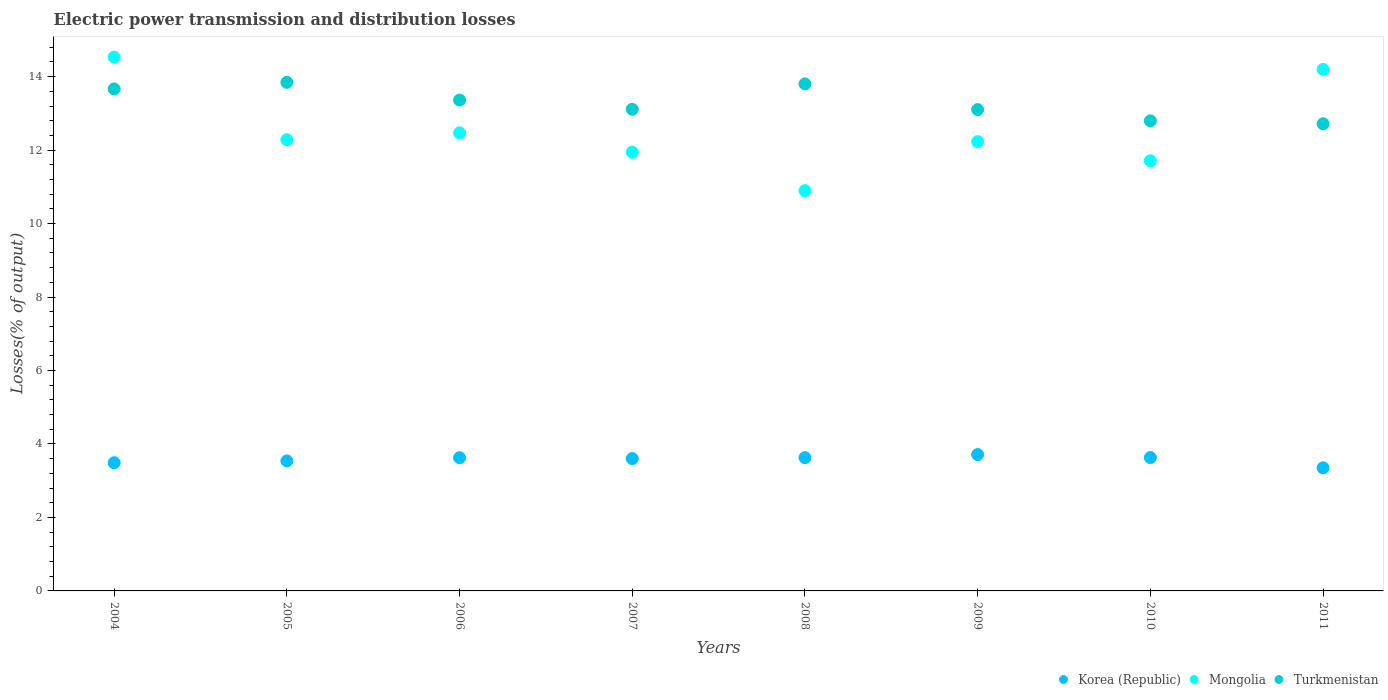Is the number of dotlines equal to the number of legend labels?
Provide a short and direct response. Yes. What is the electric power transmission and distribution losses in Korea (Republic) in 2010?
Your response must be concise. 3.63. Across all years, what is the maximum electric power transmission and distribution losses in Turkmenistan?
Ensure brevity in your answer.  13.85. Across all years, what is the minimum electric power transmission and distribution losses in Korea (Republic)?
Make the answer very short. 3.35. What is the total electric power transmission and distribution losses in Turkmenistan in the graph?
Offer a terse response. 106.41. What is the difference between the electric power transmission and distribution losses in Turkmenistan in 2010 and that in 2011?
Offer a terse response. 0.08. What is the difference between the electric power transmission and distribution losses in Turkmenistan in 2004 and the electric power transmission and distribution losses in Mongolia in 2007?
Give a very brief answer. 1.72. What is the average electric power transmission and distribution losses in Turkmenistan per year?
Your answer should be compact. 13.3. In the year 2005, what is the difference between the electric power transmission and distribution losses in Mongolia and electric power transmission and distribution losses in Turkmenistan?
Provide a short and direct response. -1.56. In how many years, is the electric power transmission and distribution losses in Mongolia greater than 1.2000000000000002 %?
Your answer should be very brief. 8. What is the ratio of the electric power transmission and distribution losses in Korea (Republic) in 2005 to that in 2007?
Your response must be concise. 0.98. Is the electric power transmission and distribution losses in Turkmenistan in 2005 less than that in 2007?
Provide a succinct answer. No. Is the difference between the electric power transmission and distribution losses in Mongolia in 2004 and 2005 greater than the difference between the electric power transmission and distribution losses in Turkmenistan in 2004 and 2005?
Your answer should be very brief. Yes. What is the difference between the highest and the second highest electric power transmission and distribution losses in Korea (Republic)?
Offer a very short reply. 0.08. What is the difference between the highest and the lowest electric power transmission and distribution losses in Mongolia?
Provide a succinct answer. 3.63. In how many years, is the electric power transmission and distribution losses in Mongolia greater than the average electric power transmission and distribution losses in Mongolia taken over all years?
Your answer should be very brief. 2. Is the electric power transmission and distribution losses in Turkmenistan strictly greater than the electric power transmission and distribution losses in Korea (Republic) over the years?
Offer a terse response. Yes. How many years are there in the graph?
Your answer should be compact. 8. What is the difference between two consecutive major ticks on the Y-axis?
Provide a short and direct response. 2. Does the graph contain grids?
Your response must be concise. No. What is the title of the graph?
Ensure brevity in your answer.  Electric power transmission and distribution losses. Does "Djibouti" appear as one of the legend labels in the graph?
Make the answer very short. No. What is the label or title of the X-axis?
Ensure brevity in your answer.  Years. What is the label or title of the Y-axis?
Ensure brevity in your answer.  Losses(% of output). What is the Losses(% of output) of Korea (Republic) in 2004?
Give a very brief answer. 3.49. What is the Losses(% of output) of Mongolia in 2004?
Make the answer very short. 14.53. What is the Losses(% of output) of Turkmenistan in 2004?
Give a very brief answer. 13.67. What is the Losses(% of output) in Korea (Republic) in 2005?
Make the answer very short. 3.54. What is the Losses(% of output) of Mongolia in 2005?
Your answer should be very brief. 12.28. What is the Losses(% of output) in Turkmenistan in 2005?
Keep it short and to the point. 13.85. What is the Losses(% of output) in Korea (Republic) in 2006?
Offer a terse response. 3.63. What is the Losses(% of output) in Mongolia in 2006?
Offer a very short reply. 12.47. What is the Losses(% of output) of Turkmenistan in 2006?
Ensure brevity in your answer.  13.36. What is the Losses(% of output) of Korea (Republic) in 2007?
Make the answer very short. 3.6. What is the Losses(% of output) in Mongolia in 2007?
Your answer should be very brief. 11.94. What is the Losses(% of output) of Turkmenistan in 2007?
Offer a terse response. 13.11. What is the Losses(% of output) of Korea (Republic) in 2008?
Offer a terse response. 3.63. What is the Losses(% of output) in Mongolia in 2008?
Keep it short and to the point. 10.9. What is the Losses(% of output) of Turkmenistan in 2008?
Give a very brief answer. 13.8. What is the Losses(% of output) in Korea (Republic) in 2009?
Provide a short and direct response. 3.71. What is the Losses(% of output) in Mongolia in 2009?
Your answer should be compact. 12.23. What is the Losses(% of output) of Turkmenistan in 2009?
Your answer should be compact. 13.1. What is the Losses(% of output) of Korea (Republic) in 2010?
Keep it short and to the point. 3.63. What is the Losses(% of output) in Mongolia in 2010?
Provide a short and direct response. 11.71. What is the Losses(% of output) in Turkmenistan in 2010?
Offer a very short reply. 12.8. What is the Losses(% of output) of Korea (Republic) in 2011?
Your response must be concise. 3.35. What is the Losses(% of output) in Mongolia in 2011?
Provide a short and direct response. 14.2. What is the Losses(% of output) of Turkmenistan in 2011?
Provide a short and direct response. 12.72. Across all years, what is the maximum Losses(% of output) in Korea (Republic)?
Make the answer very short. 3.71. Across all years, what is the maximum Losses(% of output) in Mongolia?
Provide a succinct answer. 14.53. Across all years, what is the maximum Losses(% of output) in Turkmenistan?
Your answer should be very brief. 13.85. Across all years, what is the minimum Losses(% of output) of Korea (Republic)?
Your answer should be compact. 3.35. Across all years, what is the minimum Losses(% of output) of Mongolia?
Keep it short and to the point. 10.9. Across all years, what is the minimum Losses(% of output) of Turkmenistan?
Make the answer very short. 12.72. What is the total Losses(% of output) of Korea (Republic) in the graph?
Give a very brief answer. 28.58. What is the total Losses(% of output) of Mongolia in the graph?
Provide a succinct answer. 100.27. What is the total Losses(% of output) in Turkmenistan in the graph?
Offer a very short reply. 106.41. What is the difference between the Losses(% of output) of Korea (Republic) in 2004 and that in 2005?
Provide a short and direct response. -0.05. What is the difference between the Losses(% of output) in Mongolia in 2004 and that in 2005?
Your answer should be compact. 2.25. What is the difference between the Losses(% of output) of Turkmenistan in 2004 and that in 2005?
Keep it short and to the point. -0.18. What is the difference between the Losses(% of output) in Korea (Republic) in 2004 and that in 2006?
Make the answer very short. -0.14. What is the difference between the Losses(% of output) of Mongolia in 2004 and that in 2006?
Offer a terse response. 2.06. What is the difference between the Losses(% of output) in Turkmenistan in 2004 and that in 2006?
Your answer should be compact. 0.3. What is the difference between the Losses(% of output) of Korea (Republic) in 2004 and that in 2007?
Offer a terse response. -0.11. What is the difference between the Losses(% of output) of Mongolia in 2004 and that in 2007?
Your response must be concise. 2.59. What is the difference between the Losses(% of output) in Turkmenistan in 2004 and that in 2007?
Provide a succinct answer. 0.55. What is the difference between the Losses(% of output) in Korea (Republic) in 2004 and that in 2008?
Make the answer very short. -0.14. What is the difference between the Losses(% of output) in Mongolia in 2004 and that in 2008?
Provide a short and direct response. 3.63. What is the difference between the Losses(% of output) in Turkmenistan in 2004 and that in 2008?
Give a very brief answer. -0.14. What is the difference between the Losses(% of output) of Korea (Republic) in 2004 and that in 2009?
Give a very brief answer. -0.22. What is the difference between the Losses(% of output) of Mongolia in 2004 and that in 2009?
Make the answer very short. 2.3. What is the difference between the Losses(% of output) of Turkmenistan in 2004 and that in 2009?
Provide a succinct answer. 0.56. What is the difference between the Losses(% of output) in Korea (Republic) in 2004 and that in 2010?
Your response must be concise. -0.14. What is the difference between the Losses(% of output) in Mongolia in 2004 and that in 2010?
Your response must be concise. 2.82. What is the difference between the Losses(% of output) in Turkmenistan in 2004 and that in 2010?
Give a very brief answer. 0.87. What is the difference between the Losses(% of output) in Korea (Republic) in 2004 and that in 2011?
Your response must be concise. 0.14. What is the difference between the Losses(% of output) of Mongolia in 2004 and that in 2011?
Offer a very short reply. 0.33. What is the difference between the Losses(% of output) of Turkmenistan in 2004 and that in 2011?
Your answer should be compact. 0.95. What is the difference between the Losses(% of output) of Korea (Republic) in 2005 and that in 2006?
Offer a terse response. -0.09. What is the difference between the Losses(% of output) of Mongolia in 2005 and that in 2006?
Your answer should be very brief. -0.19. What is the difference between the Losses(% of output) in Turkmenistan in 2005 and that in 2006?
Your response must be concise. 0.48. What is the difference between the Losses(% of output) of Korea (Republic) in 2005 and that in 2007?
Ensure brevity in your answer.  -0.06. What is the difference between the Losses(% of output) of Mongolia in 2005 and that in 2007?
Your response must be concise. 0.34. What is the difference between the Losses(% of output) of Turkmenistan in 2005 and that in 2007?
Provide a short and direct response. 0.73. What is the difference between the Losses(% of output) of Korea (Republic) in 2005 and that in 2008?
Your answer should be compact. -0.09. What is the difference between the Losses(% of output) in Mongolia in 2005 and that in 2008?
Keep it short and to the point. 1.39. What is the difference between the Losses(% of output) in Turkmenistan in 2005 and that in 2008?
Keep it short and to the point. 0.04. What is the difference between the Losses(% of output) in Korea (Republic) in 2005 and that in 2009?
Make the answer very short. -0.17. What is the difference between the Losses(% of output) of Mongolia in 2005 and that in 2009?
Your response must be concise. 0.05. What is the difference between the Losses(% of output) in Turkmenistan in 2005 and that in 2009?
Make the answer very short. 0.74. What is the difference between the Losses(% of output) in Korea (Republic) in 2005 and that in 2010?
Your answer should be compact. -0.09. What is the difference between the Losses(% of output) of Mongolia in 2005 and that in 2010?
Offer a terse response. 0.58. What is the difference between the Losses(% of output) in Turkmenistan in 2005 and that in 2010?
Make the answer very short. 1.05. What is the difference between the Losses(% of output) in Korea (Republic) in 2005 and that in 2011?
Offer a terse response. 0.19. What is the difference between the Losses(% of output) in Mongolia in 2005 and that in 2011?
Make the answer very short. -1.91. What is the difference between the Losses(% of output) of Turkmenistan in 2005 and that in 2011?
Ensure brevity in your answer.  1.13. What is the difference between the Losses(% of output) of Korea (Republic) in 2006 and that in 2007?
Provide a short and direct response. 0.02. What is the difference between the Losses(% of output) of Mongolia in 2006 and that in 2007?
Offer a terse response. 0.53. What is the difference between the Losses(% of output) of Turkmenistan in 2006 and that in 2007?
Keep it short and to the point. 0.25. What is the difference between the Losses(% of output) in Korea (Republic) in 2006 and that in 2008?
Your response must be concise. -0. What is the difference between the Losses(% of output) in Mongolia in 2006 and that in 2008?
Offer a very short reply. 1.57. What is the difference between the Losses(% of output) in Turkmenistan in 2006 and that in 2008?
Your answer should be very brief. -0.44. What is the difference between the Losses(% of output) in Korea (Republic) in 2006 and that in 2009?
Offer a very short reply. -0.09. What is the difference between the Losses(% of output) of Mongolia in 2006 and that in 2009?
Ensure brevity in your answer.  0.24. What is the difference between the Losses(% of output) of Turkmenistan in 2006 and that in 2009?
Your answer should be very brief. 0.26. What is the difference between the Losses(% of output) of Korea (Republic) in 2006 and that in 2010?
Your answer should be very brief. -0. What is the difference between the Losses(% of output) of Mongolia in 2006 and that in 2010?
Your response must be concise. 0.76. What is the difference between the Losses(% of output) of Turkmenistan in 2006 and that in 2010?
Make the answer very short. 0.57. What is the difference between the Losses(% of output) of Korea (Republic) in 2006 and that in 2011?
Offer a very short reply. 0.27. What is the difference between the Losses(% of output) of Mongolia in 2006 and that in 2011?
Provide a short and direct response. -1.73. What is the difference between the Losses(% of output) in Turkmenistan in 2006 and that in 2011?
Provide a short and direct response. 0.64. What is the difference between the Losses(% of output) in Korea (Republic) in 2007 and that in 2008?
Offer a terse response. -0.03. What is the difference between the Losses(% of output) in Mongolia in 2007 and that in 2008?
Give a very brief answer. 1.05. What is the difference between the Losses(% of output) of Turkmenistan in 2007 and that in 2008?
Your response must be concise. -0.69. What is the difference between the Losses(% of output) of Korea (Republic) in 2007 and that in 2009?
Your response must be concise. -0.11. What is the difference between the Losses(% of output) of Mongolia in 2007 and that in 2009?
Offer a terse response. -0.29. What is the difference between the Losses(% of output) in Turkmenistan in 2007 and that in 2009?
Provide a succinct answer. 0.01. What is the difference between the Losses(% of output) in Korea (Republic) in 2007 and that in 2010?
Ensure brevity in your answer.  -0.03. What is the difference between the Losses(% of output) of Mongolia in 2007 and that in 2010?
Your response must be concise. 0.23. What is the difference between the Losses(% of output) of Turkmenistan in 2007 and that in 2010?
Your answer should be very brief. 0.31. What is the difference between the Losses(% of output) in Korea (Republic) in 2007 and that in 2011?
Your response must be concise. 0.25. What is the difference between the Losses(% of output) in Mongolia in 2007 and that in 2011?
Offer a terse response. -2.25. What is the difference between the Losses(% of output) in Turkmenistan in 2007 and that in 2011?
Keep it short and to the point. 0.39. What is the difference between the Losses(% of output) in Korea (Republic) in 2008 and that in 2009?
Provide a succinct answer. -0.08. What is the difference between the Losses(% of output) of Mongolia in 2008 and that in 2009?
Provide a short and direct response. -1.33. What is the difference between the Losses(% of output) of Turkmenistan in 2008 and that in 2009?
Give a very brief answer. 0.7. What is the difference between the Losses(% of output) of Korea (Republic) in 2008 and that in 2010?
Offer a very short reply. -0. What is the difference between the Losses(% of output) of Mongolia in 2008 and that in 2010?
Keep it short and to the point. -0.81. What is the difference between the Losses(% of output) in Korea (Republic) in 2008 and that in 2011?
Provide a short and direct response. 0.28. What is the difference between the Losses(% of output) of Mongolia in 2008 and that in 2011?
Your answer should be compact. -3.3. What is the difference between the Losses(% of output) of Turkmenistan in 2008 and that in 2011?
Provide a short and direct response. 1.09. What is the difference between the Losses(% of output) in Korea (Republic) in 2009 and that in 2010?
Provide a succinct answer. 0.08. What is the difference between the Losses(% of output) of Mongolia in 2009 and that in 2010?
Your answer should be very brief. 0.52. What is the difference between the Losses(% of output) of Turkmenistan in 2009 and that in 2010?
Keep it short and to the point. 0.31. What is the difference between the Losses(% of output) of Korea (Republic) in 2009 and that in 2011?
Give a very brief answer. 0.36. What is the difference between the Losses(% of output) in Mongolia in 2009 and that in 2011?
Provide a short and direct response. -1.97. What is the difference between the Losses(% of output) of Turkmenistan in 2009 and that in 2011?
Offer a terse response. 0.39. What is the difference between the Losses(% of output) in Korea (Republic) in 2010 and that in 2011?
Provide a succinct answer. 0.28. What is the difference between the Losses(% of output) of Mongolia in 2010 and that in 2011?
Make the answer very short. -2.49. What is the difference between the Losses(% of output) of Turkmenistan in 2010 and that in 2011?
Give a very brief answer. 0.08. What is the difference between the Losses(% of output) of Korea (Republic) in 2004 and the Losses(% of output) of Mongolia in 2005?
Ensure brevity in your answer.  -8.79. What is the difference between the Losses(% of output) of Korea (Republic) in 2004 and the Losses(% of output) of Turkmenistan in 2005?
Ensure brevity in your answer.  -10.36. What is the difference between the Losses(% of output) in Mongolia in 2004 and the Losses(% of output) in Turkmenistan in 2005?
Provide a short and direct response. 0.69. What is the difference between the Losses(% of output) in Korea (Republic) in 2004 and the Losses(% of output) in Mongolia in 2006?
Your answer should be compact. -8.98. What is the difference between the Losses(% of output) in Korea (Republic) in 2004 and the Losses(% of output) in Turkmenistan in 2006?
Your answer should be compact. -9.87. What is the difference between the Losses(% of output) of Mongolia in 2004 and the Losses(% of output) of Turkmenistan in 2006?
Offer a terse response. 1.17. What is the difference between the Losses(% of output) of Korea (Republic) in 2004 and the Losses(% of output) of Mongolia in 2007?
Keep it short and to the point. -8.45. What is the difference between the Losses(% of output) in Korea (Republic) in 2004 and the Losses(% of output) in Turkmenistan in 2007?
Offer a very short reply. -9.62. What is the difference between the Losses(% of output) in Mongolia in 2004 and the Losses(% of output) in Turkmenistan in 2007?
Give a very brief answer. 1.42. What is the difference between the Losses(% of output) of Korea (Republic) in 2004 and the Losses(% of output) of Mongolia in 2008?
Keep it short and to the point. -7.41. What is the difference between the Losses(% of output) of Korea (Republic) in 2004 and the Losses(% of output) of Turkmenistan in 2008?
Offer a terse response. -10.31. What is the difference between the Losses(% of output) of Mongolia in 2004 and the Losses(% of output) of Turkmenistan in 2008?
Your answer should be very brief. 0.73. What is the difference between the Losses(% of output) in Korea (Republic) in 2004 and the Losses(% of output) in Mongolia in 2009?
Give a very brief answer. -8.74. What is the difference between the Losses(% of output) in Korea (Republic) in 2004 and the Losses(% of output) in Turkmenistan in 2009?
Your answer should be compact. -9.61. What is the difference between the Losses(% of output) in Mongolia in 2004 and the Losses(% of output) in Turkmenistan in 2009?
Your answer should be very brief. 1.43. What is the difference between the Losses(% of output) in Korea (Republic) in 2004 and the Losses(% of output) in Mongolia in 2010?
Provide a succinct answer. -8.22. What is the difference between the Losses(% of output) of Korea (Republic) in 2004 and the Losses(% of output) of Turkmenistan in 2010?
Your response must be concise. -9.31. What is the difference between the Losses(% of output) of Mongolia in 2004 and the Losses(% of output) of Turkmenistan in 2010?
Provide a short and direct response. 1.74. What is the difference between the Losses(% of output) in Korea (Republic) in 2004 and the Losses(% of output) in Mongolia in 2011?
Provide a succinct answer. -10.71. What is the difference between the Losses(% of output) of Korea (Republic) in 2004 and the Losses(% of output) of Turkmenistan in 2011?
Ensure brevity in your answer.  -9.23. What is the difference between the Losses(% of output) in Mongolia in 2004 and the Losses(% of output) in Turkmenistan in 2011?
Offer a terse response. 1.81. What is the difference between the Losses(% of output) of Korea (Republic) in 2005 and the Losses(% of output) of Mongolia in 2006?
Keep it short and to the point. -8.93. What is the difference between the Losses(% of output) of Korea (Republic) in 2005 and the Losses(% of output) of Turkmenistan in 2006?
Give a very brief answer. -9.82. What is the difference between the Losses(% of output) in Mongolia in 2005 and the Losses(% of output) in Turkmenistan in 2006?
Your response must be concise. -1.08. What is the difference between the Losses(% of output) of Korea (Republic) in 2005 and the Losses(% of output) of Mongolia in 2007?
Keep it short and to the point. -8.4. What is the difference between the Losses(% of output) of Korea (Republic) in 2005 and the Losses(% of output) of Turkmenistan in 2007?
Keep it short and to the point. -9.57. What is the difference between the Losses(% of output) of Mongolia in 2005 and the Losses(% of output) of Turkmenistan in 2007?
Provide a short and direct response. -0.83. What is the difference between the Losses(% of output) of Korea (Republic) in 2005 and the Losses(% of output) of Mongolia in 2008?
Make the answer very short. -7.36. What is the difference between the Losses(% of output) in Korea (Republic) in 2005 and the Losses(% of output) in Turkmenistan in 2008?
Provide a short and direct response. -10.26. What is the difference between the Losses(% of output) in Mongolia in 2005 and the Losses(% of output) in Turkmenistan in 2008?
Give a very brief answer. -1.52. What is the difference between the Losses(% of output) of Korea (Republic) in 2005 and the Losses(% of output) of Mongolia in 2009?
Make the answer very short. -8.69. What is the difference between the Losses(% of output) of Korea (Republic) in 2005 and the Losses(% of output) of Turkmenistan in 2009?
Offer a terse response. -9.56. What is the difference between the Losses(% of output) in Mongolia in 2005 and the Losses(% of output) in Turkmenistan in 2009?
Provide a succinct answer. -0.82. What is the difference between the Losses(% of output) of Korea (Republic) in 2005 and the Losses(% of output) of Mongolia in 2010?
Your response must be concise. -8.17. What is the difference between the Losses(% of output) of Korea (Republic) in 2005 and the Losses(% of output) of Turkmenistan in 2010?
Ensure brevity in your answer.  -9.26. What is the difference between the Losses(% of output) in Mongolia in 2005 and the Losses(% of output) in Turkmenistan in 2010?
Your answer should be compact. -0.51. What is the difference between the Losses(% of output) in Korea (Republic) in 2005 and the Losses(% of output) in Mongolia in 2011?
Your response must be concise. -10.66. What is the difference between the Losses(% of output) of Korea (Republic) in 2005 and the Losses(% of output) of Turkmenistan in 2011?
Offer a terse response. -9.18. What is the difference between the Losses(% of output) in Mongolia in 2005 and the Losses(% of output) in Turkmenistan in 2011?
Your response must be concise. -0.43. What is the difference between the Losses(% of output) in Korea (Republic) in 2006 and the Losses(% of output) in Mongolia in 2007?
Your response must be concise. -8.32. What is the difference between the Losses(% of output) of Korea (Republic) in 2006 and the Losses(% of output) of Turkmenistan in 2007?
Provide a short and direct response. -9.49. What is the difference between the Losses(% of output) in Mongolia in 2006 and the Losses(% of output) in Turkmenistan in 2007?
Provide a succinct answer. -0.64. What is the difference between the Losses(% of output) in Korea (Republic) in 2006 and the Losses(% of output) in Mongolia in 2008?
Offer a very short reply. -7.27. What is the difference between the Losses(% of output) in Korea (Republic) in 2006 and the Losses(% of output) in Turkmenistan in 2008?
Offer a terse response. -10.18. What is the difference between the Losses(% of output) of Mongolia in 2006 and the Losses(% of output) of Turkmenistan in 2008?
Provide a short and direct response. -1.33. What is the difference between the Losses(% of output) in Korea (Republic) in 2006 and the Losses(% of output) in Mongolia in 2009?
Provide a succinct answer. -8.6. What is the difference between the Losses(% of output) of Korea (Republic) in 2006 and the Losses(% of output) of Turkmenistan in 2009?
Provide a short and direct response. -9.48. What is the difference between the Losses(% of output) of Mongolia in 2006 and the Losses(% of output) of Turkmenistan in 2009?
Your response must be concise. -0.63. What is the difference between the Losses(% of output) of Korea (Republic) in 2006 and the Losses(% of output) of Mongolia in 2010?
Your response must be concise. -8.08. What is the difference between the Losses(% of output) in Korea (Republic) in 2006 and the Losses(% of output) in Turkmenistan in 2010?
Keep it short and to the point. -9.17. What is the difference between the Losses(% of output) of Mongolia in 2006 and the Losses(% of output) of Turkmenistan in 2010?
Your answer should be very brief. -0.33. What is the difference between the Losses(% of output) of Korea (Republic) in 2006 and the Losses(% of output) of Mongolia in 2011?
Your response must be concise. -10.57. What is the difference between the Losses(% of output) of Korea (Republic) in 2006 and the Losses(% of output) of Turkmenistan in 2011?
Ensure brevity in your answer.  -9.09. What is the difference between the Losses(% of output) of Mongolia in 2006 and the Losses(% of output) of Turkmenistan in 2011?
Provide a short and direct response. -0.25. What is the difference between the Losses(% of output) in Korea (Republic) in 2007 and the Losses(% of output) in Mongolia in 2008?
Your response must be concise. -7.29. What is the difference between the Losses(% of output) in Korea (Republic) in 2007 and the Losses(% of output) in Turkmenistan in 2008?
Give a very brief answer. -10.2. What is the difference between the Losses(% of output) of Mongolia in 2007 and the Losses(% of output) of Turkmenistan in 2008?
Your answer should be compact. -1.86. What is the difference between the Losses(% of output) of Korea (Republic) in 2007 and the Losses(% of output) of Mongolia in 2009?
Provide a succinct answer. -8.63. What is the difference between the Losses(% of output) in Korea (Republic) in 2007 and the Losses(% of output) in Turkmenistan in 2009?
Keep it short and to the point. -9.5. What is the difference between the Losses(% of output) of Mongolia in 2007 and the Losses(% of output) of Turkmenistan in 2009?
Ensure brevity in your answer.  -1.16. What is the difference between the Losses(% of output) in Korea (Republic) in 2007 and the Losses(% of output) in Mongolia in 2010?
Provide a short and direct response. -8.11. What is the difference between the Losses(% of output) of Korea (Republic) in 2007 and the Losses(% of output) of Turkmenistan in 2010?
Provide a succinct answer. -9.19. What is the difference between the Losses(% of output) of Mongolia in 2007 and the Losses(% of output) of Turkmenistan in 2010?
Make the answer very short. -0.85. What is the difference between the Losses(% of output) in Korea (Republic) in 2007 and the Losses(% of output) in Mongolia in 2011?
Give a very brief answer. -10.59. What is the difference between the Losses(% of output) in Korea (Republic) in 2007 and the Losses(% of output) in Turkmenistan in 2011?
Ensure brevity in your answer.  -9.11. What is the difference between the Losses(% of output) of Mongolia in 2007 and the Losses(% of output) of Turkmenistan in 2011?
Your answer should be very brief. -0.78. What is the difference between the Losses(% of output) in Korea (Republic) in 2008 and the Losses(% of output) in Mongolia in 2009?
Provide a short and direct response. -8.6. What is the difference between the Losses(% of output) in Korea (Republic) in 2008 and the Losses(% of output) in Turkmenistan in 2009?
Your answer should be compact. -9.48. What is the difference between the Losses(% of output) of Mongolia in 2008 and the Losses(% of output) of Turkmenistan in 2009?
Provide a succinct answer. -2.21. What is the difference between the Losses(% of output) in Korea (Republic) in 2008 and the Losses(% of output) in Mongolia in 2010?
Provide a succinct answer. -8.08. What is the difference between the Losses(% of output) in Korea (Republic) in 2008 and the Losses(% of output) in Turkmenistan in 2010?
Your answer should be very brief. -9.17. What is the difference between the Losses(% of output) in Mongolia in 2008 and the Losses(% of output) in Turkmenistan in 2010?
Offer a very short reply. -1.9. What is the difference between the Losses(% of output) in Korea (Republic) in 2008 and the Losses(% of output) in Mongolia in 2011?
Give a very brief answer. -10.57. What is the difference between the Losses(% of output) in Korea (Republic) in 2008 and the Losses(% of output) in Turkmenistan in 2011?
Make the answer very short. -9.09. What is the difference between the Losses(% of output) of Mongolia in 2008 and the Losses(% of output) of Turkmenistan in 2011?
Your answer should be compact. -1.82. What is the difference between the Losses(% of output) of Korea (Republic) in 2009 and the Losses(% of output) of Mongolia in 2010?
Your response must be concise. -8. What is the difference between the Losses(% of output) of Korea (Republic) in 2009 and the Losses(% of output) of Turkmenistan in 2010?
Your response must be concise. -9.08. What is the difference between the Losses(% of output) in Mongolia in 2009 and the Losses(% of output) in Turkmenistan in 2010?
Make the answer very short. -0.57. What is the difference between the Losses(% of output) in Korea (Republic) in 2009 and the Losses(% of output) in Mongolia in 2011?
Ensure brevity in your answer.  -10.48. What is the difference between the Losses(% of output) in Korea (Republic) in 2009 and the Losses(% of output) in Turkmenistan in 2011?
Make the answer very short. -9. What is the difference between the Losses(% of output) of Mongolia in 2009 and the Losses(% of output) of Turkmenistan in 2011?
Your answer should be compact. -0.49. What is the difference between the Losses(% of output) in Korea (Republic) in 2010 and the Losses(% of output) in Mongolia in 2011?
Provide a succinct answer. -10.57. What is the difference between the Losses(% of output) in Korea (Republic) in 2010 and the Losses(% of output) in Turkmenistan in 2011?
Your answer should be compact. -9.09. What is the difference between the Losses(% of output) of Mongolia in 2010 and the Losses(% of output) of Turkmenistan in 2011?
Your answer should be compact. -1.01. What is the average Losses(% of output) in Korea (Republic) per year?
Your answer should be compact. 3.57. What is the average Losses(% of output) in Mongolia per year?
Your response must be concise. 12.53. What is the average Losses(% of output) in Turkmenistan per year?
Ensure brevity in your answer.  13.3. In the year 2004, what is the difference between the Losses(% of output) of Korea (Republic) and Losses(% of output) of Mongolia?
Provide a succinct answer. -11.04. In the year 2004, what is the difference between the Losses(% of output) in Korea (Republic) and Losses(% of output) in Turkmenistan?
Offer a very short reply. -10.18. In the year 2004, what is the difference between the Losses(% of output) of Mongolia and Losses(% of output) of Turkmenistan?
Ensure brevity in your answer.  0.87. In the year 2005, what is the difference between the Losses(% of output) of Korea (Republic) and Losses(% of output) of Mongolia?
Your answer should be very brief. -8.74. In the year 2005, what is the difference between the Losses(% of output) of Korea (Republic) and Losses(% of output) of Turkmenistan?
Give a very brief answer. -10.31. In the year 2005, what is the difference between the Losses(% of output) of Mongolia and Losses(% of output) of Turkmenistan?
Offer a very short reply. -1.56. In the year 2006, what is the difference between the Losses(% of output) of Korea (Republic) and Losses(% of output) of Mongolia?
Offer a terse response. -8.85. In the year 2006, what is the difference between the Losses(% of output) in Korea (Republic) and Losses(% of output) in Turkmenistan?
Keep it short and to the point. -9.74. In the year 2006, what is the difference between the Losses(% of output) of Mongolia and Losses(% of output) of Turkmenistan?
Offer a very short reply. -0.89. In the year 2007, what is the difference between the Losses(% of output) in Korea (Republic) and Losses(% of output) in Mongolia?
Your answer should be compact. -8.34. In the year 2007, what is the difference between the Losses(% of output) of Korea (Republic) and Losses(% of output) of Turkmenistan?
Make the answer very short. -9.51. In the year 2007, what is the difference between the Losses(% of output) in Mongolia and Losses(% of output) in Turkmenistan?
Make the answer very short. -1.17. In the year 2008, what is the difference between the Losses(% of output) in Korea (Republic) and Losses(% of output) in Mongolia?
Provide a short and direct response. -7.27. In the year 2008, what is the difference between the Losses(% of output) in Korea (Republic) and Losses(% of output) in Turkmenistan?
Offer a very short reply. -10.18. In the year 2008, what is the difference between the Losses(% of output) of Mongolia and Losses(% of output) of Turkmenistan?
Ensure brevity in your answer.  -2.91. In the year 2009, what is the difference between the Losses(% of output) in Korea (Republic) and Losses(% of output) in Mongolia?
Provide a short and direct response. -8.52. In the year 2009, what is the difference between the Losses(% of output) of Korea (Republic) and Losses(% of output) of Turkmenistan?
Your response must be concise. -9.39. In the year 2009, what is the difference between the Losses(% of output) in Mongolia and Losses(% of output) in Turkmenistan?
Offer a very short reply. -0.87. In the year 2010, what is the difference between the Losses(% of output) in Korea (Republic) and Losses(% of output) in Mongolia?
Ensure brevity in your answer.  -8.08. In the year 2010, what is the difference between the Losses(% of output) of Korea (Republic) and Losses(% of output) of Turkmenistan?
Your response must be concise. -9.17. In the year 2010, what is the difference between the Losses(% of output) in Mongolia and Losses(% of output) in Turkmenistan?
Ensure brevity in your answer.  -1.09. In the year 2011, what is the difference between the Losses(% of output) of Korea (Republic) and Losses(% of output) of Mongolia?
Ensure brevity in your answer.  -10.85. In the year 2011, what is the difference between the Losses(% of output) of Korea (Republic) and Losses(% of output) of Turkmenistan?
Keep it short and to the point. -9.37. In the year 2011, what is the difference between the Losses(% of output) in Mongolia and Losses(% of output) in Turkmenistan?
Offer a very short reply. 1.48. What is the ratio of the Losses(% of output) of Mongolia in 2004 to that in 2005?
Offer a very short reply. 1.18. What is the ratio of the Losses(% of output) in Turkmenistan in 2004 to that in 2005?
Ensure brevity in your answer.  0.99. What is the ratio of the Losses(% of output) in Korea (Republic) in 2004 to that in 2006?
Your response must be concise. 0.96. What is the ratio of the Losses(% of output) of Mongolia in 2004 to that in 2006?
Make the answer very short. 1.17. What is the ratio of the Losses(% of output) of Turkmenistan in 2004 to that in 2006?
Your answer should be compact. 1.02. What is the ratio of the Losses(% of output) of Korea (Republic) in 2004 to that in 2007?
Your answer should be compact. 0.97. What is the ratio of the Losses(% of output) in Mongolia in 2004 to that in 2007?
Make the answer very short. 1.22. What is the ratio of the Losses(% of output) in Turkmenistan in 2004 to that in 2007?
Give a very brief answer. 1.04. What is the ratio of the Losses(% of output) in Korea (Republic) in 2004 to that in 2008?
Provide a short and direct response. 0.96. What is the ratio of the Losses(% of output) of Mongolia in 2004 to that in 2008?
Your response must be concise. 1.33. What is the ratio of the Losses(% of output) of Korea (Republic) in 2004 to that in 2009?
Offer a terse response. 0.94. What is the ratio of the Losses(% of output) in Mongolia in 2004 to that in 2009?
Your response must be concise. 1.19. What is the ratio of the Losses(% of output) in Turkmenistan in 2004 to that in 2009?
Offer a very short reply. 1.04. What is the ratio of the Losses(% of output) in Korea (Republic) in 2004 to that in 2010?
Keep it short and to the point. 0.96. What is the ratio of the Losses(% of output) in Mongolia in 2004 to that in 2010?
Give a very brief answer. 1.24. What is the ratio of the Losses(% of output) in Turkmenistan in 2004 to that in 2010?
Provide a short and direct response. 1.07. What is the ratio of the Losses(% of output) in Korea (Republic) in 2004 to that in 2011?
Keep it short and to the point. 1.04. What is the ratio of the Losses(% of output) in Mongolia in 2004 to that in 2011?
Your answer should be very brief. 1.02. What is the ratio of the Losses(% of output) of Turkmenistan in 2004 to that in 2011?
Make the answer very short. 1.07. What is the ratio of the Losses(% of output) in Korea (Republic) in 2005 to that in 2006?
Your answer should be very brief. 0.98. What is the ratio of the Losses(% of output) in Mongolia in 2005 to that in 2006?
Offer a very short reply. 0.98. What is the ratio of the Losses(% of output) in Turkmenistan in 2005 to that in 2006?
Make the answer very short. 1.04. What is the ratio of the Losses(% of output) of Korea (Republic) in 2005 to that in 2007?
Offer a very short reply. 0.98. What is the ratio of the Losses(% of output) in Mongolia in 2005 to that in 2007?
Make the answer very short. 1.03. What is the ratio of the Losses(% of output) of Turkmenistan in 2005 to that in 2007?
Your answer should be compact. 1.06. What is the ratio of the Losses(% of output) in Korea (Republic) in 2005 to that in 2008?
Keep it short and to the point. 0.98. What is the ratio of the Losses(% of output) of Mongolia in 2005 to that in 2008?
Provide a succinct answer. 1.13. What is the ratio of the Losses(% of output) of Turkmenistan in 2005 to that in 2008?
Your answer should be very brief. 1. What is the ratio of the Losses(% of output) in Korea (Republic) in 2005 to that in 2009?
Provide a succinct answer. 0.95. What is the ratio of the Losses(% of output) in Mongolia in 2005 to that in 2009?
Your answer should be compact. 1. What is the ratio of the Losses(% of output) of Turkmenistan in 2005 to that in 2009?
Make the answer very short. 1.06. What is the ratio of the Losses(% of output) of Korea (Republic) in 2005 to that in 2010?
Offer a very short reply. 0.97. What is the ratio of the Losses(% of output) in Mongolia in 2005 to that in 2010?
Provide a succinct answer. 1.05. What is the ratio of the Losses(% of output) of Turkmenistan in 2005 to that in 2010?
Give a very brief answer. 1.08. What is the ratio of the Losses(% of output) of Korea (Republic) in 2005 to that in 2011?
Ensure brevity in your answer.  1.06. What is the ratio of the Losses(% of output) in Mongolia in 2005 to that in 2011?
Make the answer very short. 0.87. What is the ratio of the Losses(% of output) in Turkmenistan in 2005 to that in 2011?
Your response must be concise. 1.09. What is the ratio of the Losses(% of output) in Mongolia in 2006 to that in 2007?
Your answer should be very brief. 1.04. What is the ratio of the Losses(% of output) of Turkmenistan in 2006 to that in 2007?
Your response must be concise. 1.02. What is the ratio of the Losses(% of output) in Korea (Republic) in 2006 to that in 2008?
Ensure brevity in your answer.  1. What is the ratio of the Losses(% of output) of Mongolia in 2006 to that in 2008?
Provide a succinct answer. 1.14. What is the ratio of the Losses(% of output) in Turkmenistan in 2006 to that in 2008?
Keep it short and to the point. 0.97. What is the ratio of the Losses(% of output) of Korea (Republic) in 2006 to that in 2009?
Your answer should be very brief. 0.98. What is the ratio of the Losses(% of output) in Mongolia in 2006 to that in 2009?
Make the answer very short. 1.02. What is the ratio of the Losses(% of output) of Turkmenistan in 2006 to that in 2009?
Offer a terse response. 1.02. What is the ratio of the Losses(% of output) in Mongolia in 2006 to that in 2010?
Keep it short and to the point. 1.07. What is the ratio of the Losses(% of output) of Turkmenistan in 2006 to that in 2010?
Ensure brevity in your answer.  1.04. What is the ratio of the Losses(% of output) of Korea (Republic) in 2006 to that in 2011?
Your response must be concise. 1.08. What is the ratio of the Losses(% of output) of Mongolia in 2006 to that in 2011?
Give a very brief answer. 0.88. What is the ratio of the Losses(% of output) in Turkmenistan in 2006 to that in 2011?
Give a very brief answer. 1.05. What is the ratio of the Losses(% of output) in Mongolia in 2007 to that in 2008?
Offer a terse response. 1.1. What is the ratio of the Losses(% of output) of Turkmenistan in 2007 to that in 2008?
Offer a terse response. 0.95. What is the ratio of the Losses(% of output) in Korea (Republic) in 2007 to that in 2009?
Make the answer very short. 0.97. What is the ratio of the Losses(% of output) of Mongolia in 2007 to that in 2009?
Make the answer very short. 0.98. What is the ratio of the Losses(% of output) of Turkmenistan in 2007 to that in 2009?
Give a very brief answer. 1. What is the ratio of the Losses(% of output) in Turkmenistan in 2007 to that in 2010?
Offer a very short reply. 1.02. What is the ratio of the Losses(% of output) in Korea (Republic) in 2007 to that in 2011?
Ensure brevity in your answer.  1.07. What is the ratio of the Losses(% of output) of Mongolia in 2007 to that in 2011?
Offer a terse response. 0.84. What is the ratio of the Losses(% of output) in Turkmenistan in 2007 to that in 2011?
Keep it short and to the point. 1.03. What is the ratio of the Losses(% of output) in Korea (Republic) in 2008 to that in 2009?
Your answer should be compact. 0.98. What is the ratio of the Losses(% of output) of Mongolia in 2008 to that in 2009?
Make the answer very short. 0.89. What is the ratio of the Losses(% of output) of Turkmenistan in 2008 to that in 2009?
Keep it short and to the point. 1.05. What is the ratio of the Losses(% of output) in Mongolia in 2008 to that in 2010?
Provide a succinct answer. 0.93. What is the ratio of the Losses(% of output) of Turkmenistan in 2008 to that in 2010?
Your answer should be compact. 1.08. What is the ratio of the Losses(% of output) of Korea (Republic) in 2008 to that in 2011?
Provide a short and direct response. 1.08. What is the ratio of the Losses(% of output) of Mongolia in 2008 to that in 2011?
Ensure brevity in your answer.  0.77. What is the ratio of the Losses(% of output) of Turkmenistan in 2008 to that in 2011?
Ensure brevity in your answer.  1.09. What is the ratio of the Losses(% of output) of Korea (Republic) in 2009 to that in 2010?
Your answer should be compact. 1.02. What is the ratio of the Losses(% of output) in Mongolia in 2009 to that in 2010?
Keep it short and to the point. 1.04. What is the ratio of the Losses(% of output) of Turkmenistan in 2009 to that in 2010?
Keep it short and to the point. 1.02. What is the ratio of the Losses(% of output) of Korea (Republic) in 2009 to that in 2011?
Provide a succinct answer. 1.11. What is the ratio of the Losses(% of output) in Mongolia in 2009 to that in 2011?
Your answer should be compact. 0.86. What is the ratio of the Losses(% of output) of Turkmenistan in 2009 to that in 2011?
Keep it short and to the point. 1.03. What is the ratio of the Losses(% of output) in Mongolia in 2010 to that in 2011?
Offer a terse response. 0.82. What is the ratio of the Losses(% of output) of Turkmenistan in 2010 to that in 2011?
Make the answer very short. 1.01. What is the difference between the highest and the second highest Losses(% of output) in Korea (Republic)?
Provide a succinct answer. 0.08. What is the difference between the highest and the second highest Losses(% of output) of Mongolia?
Your answer should be very brief. 0.33. What is the difference between the highest and the second highest Losses(% of output) of Turkmenistan?
Your answer should be very brief. 0.04. What is the difference between the highest and the lowest Losses(% of output) in Korea (Republic)?
Offer a terse response. 0.36. What is the difference between the highest and the lowest Losses(% of output) in Mongolia?
Provide a short and direct response. 3.63. What is the difference between the highest and the lowest Losses(% of output) of Turkmenistan?
Provide a succinct answer. 1.13. 